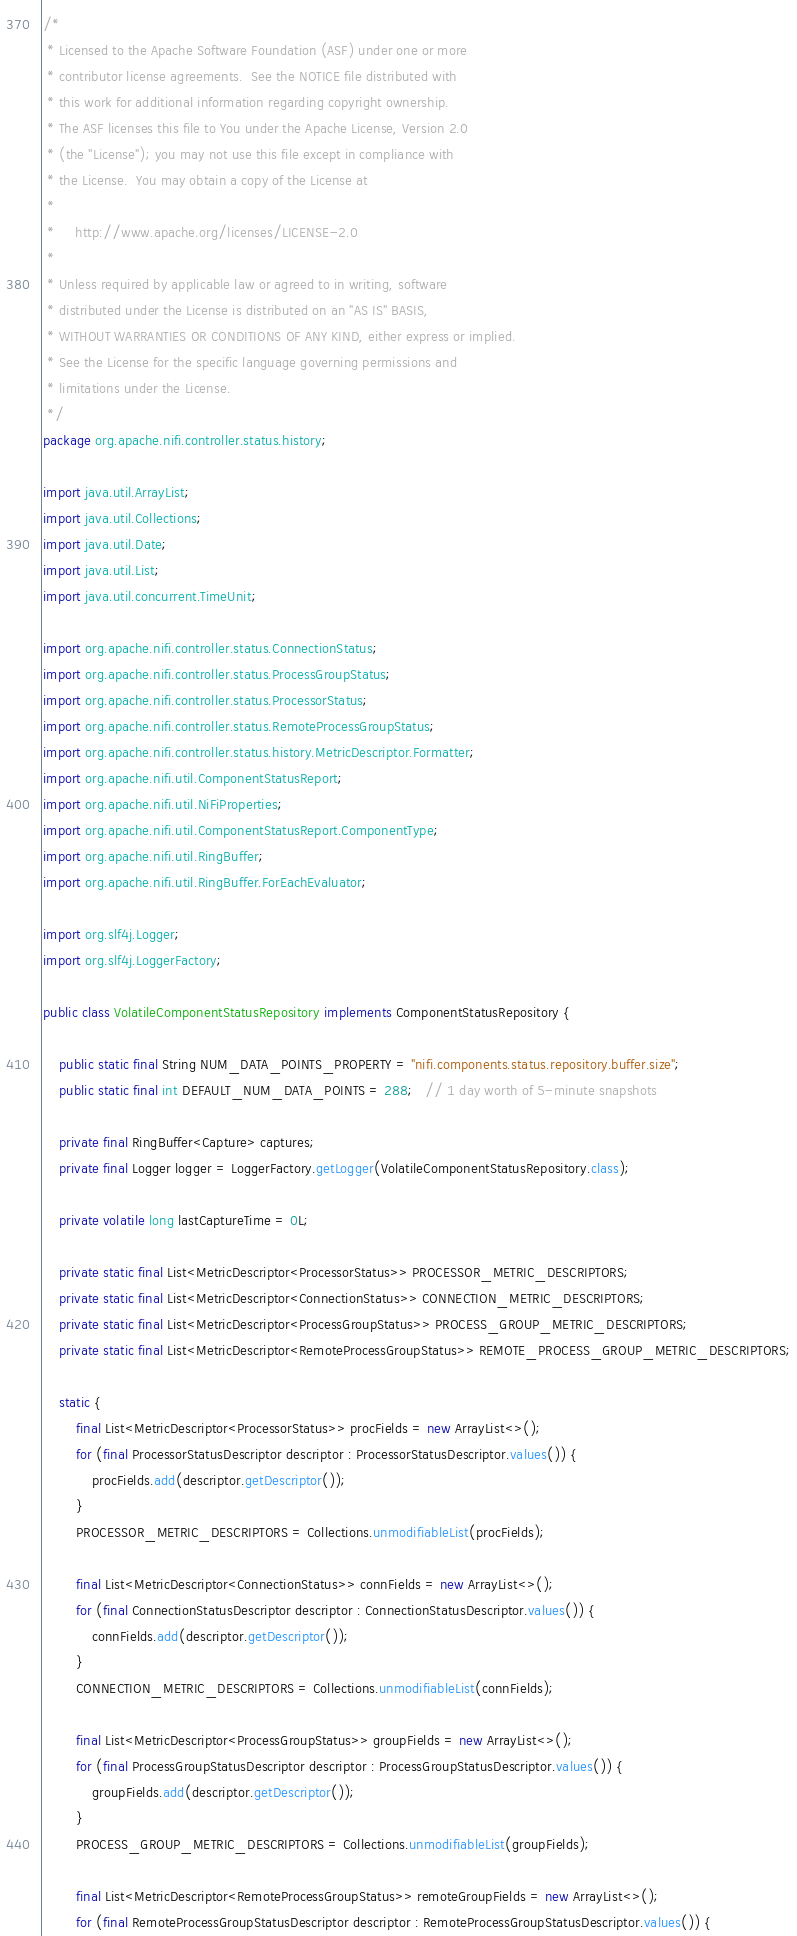Convert code to text. <code><loc_0><loc_0><loc_500><loc_500><_Java_>/*
 * Licensed to the Apache Software Foundation (ASF) under one or more
 * contributor license agreements.  See the NOTICE file distributed with
 * this work for additional information regarding copyright ownership.
 * The ASF licenses this file to You under the Apache License, Version 2.0
 * (the "License"); you may not use this file except in compliance with
 * the License.  You may obtain a copy of the License at
 *
 *     http://www.apache.org/licenses/LICENSE-2.0
 *
 * Unless required by applicable law or agreed to in writing, software
 * distributed under the License is distributed on an "AS IS" BASIS,
 * WITHOUT WARRANTIES OR CONDITIONS OF ANY KIND, either express or implied.
 * See the License for the specific language governing permissions and
 * limitations under the License.
 */
package org.apache.nifi.controller.status.history;

import java.util.ArrayList;
import java.util.Collections;
import java.util.Date;
import java.util.List;
import java.util.concurrent.TimeUnit;

import org.apache.nifi.controller.status.ConnectionStatus;
import org.apache.nifi.controller.status.ProcessGroupStatus;
import org.apache.nifi.controller.status.ProcessorStatus;
import org.apache.nifi.controller.status.RemoteProcessGroupStatus;
import org.apache.nifi.controller.status.history.MetricDescriptor.Formatter;
import org.apache.nifi.util.ComponentStatusReport;
import org.apache.nifi.util.NiFiProperties;
import org.apache.nifi.util.ComponentStatusReport.ComponentType;
import org.apache.nifi.util.RingBuffer;
import org.apache.nifi.util.RingBuffer.ForEachEvaluator;

import org.slf4j.Logger;
import org.slf4j.LoggerFactory;

public class VolatileComponentStatusRepository implements ComponentStatusRepository {

    public static final String NUM_DATA_POINTS_PROPERTY = "nifi.components.status.repository.buffer.size";
    public static final int DEFAULT_NUM_DATA_POINTS = 288;   // 1 day worth of 5-minute snapshots

    private final RingBuffer<Capture> captures;
    private final Logger logger = LoggerFactory.getLogger(VolatileComponentStatusRepository.class);

    private volatile long lastCaptureTime = 0L;

    private static final List<MetricDescriptor<ProcessorStatus>> PROCESSOR_METRIC_DESCRIPTORS;
    private static final List<MetricDescriptor<ConnectionStatus>> CONNECTION_METRIC_DESCRIPTORS;
    private static final List<MetricDescriptor<ProcessGroupStatus>> PROCESS_GROUP_METRIC_DESCRIPTORS;
    private static final List<MetricDescriptor<RemoteProcessGroupStatus>> REMOTE_PROCESS_GROUP_METRIC_DESCRIPTORS;

    static {
        final List<MetricDescriptor<ProcessorStatus>> procFields = new ArrayList<>();
        for (final ProcessorStatusDescriptor descriptor : ProcessorStatusDescriptor.values()) {
            procFields.add(descriptor.getDescriptor());
        }
        PROCESSOR_METRIC_DESCRIPTORS = Collections.unmodifiableList(procFields);

        final List<MetricDescriptor<ConnectionStatus>> connFields = new ArrayList<>();
        for (final ConnectionStatusDescriptor descriptor : ConnectionStatusDescriptor.values()) {
            connFields.add(descriptor.getDescriptor());
        }
        CONNECTION_METRIC_DESCRIPTORS = Collections.unmodifiableList(connFields);

        final List<MetricDescriptor<ProcessGroupStatus>> groupFields = new ArrayList<>();
        for (final ProcessGroupStatusDescriptor descriptor : ProcessGroupStatusDescriptor.values()) {
            groupFields.add(descriptor.getDescriptor());
        }
        PROCESS_GROUP_METRIC_DESCRIPTORS = Collections.unmodifiableList(groupFields);

        final List<MetricDescriptor<RemoteProcessGroupStatus>> remoteGroupFields = new ArrayList<>();
        for (final RemoteProcessGroupStatusDescriptor descriptor : RemoteProcessGroupStatusDescriptor.values()) {</code> 